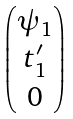Convert formula to latex. <formula><loc_0><loc_0><loc_500><loc_500>\begin{pmatrix} \psi _ { 1 } \\ t ^ { \prime } _ { 1 } \\ 0 \end{pmatrix}</formula> 